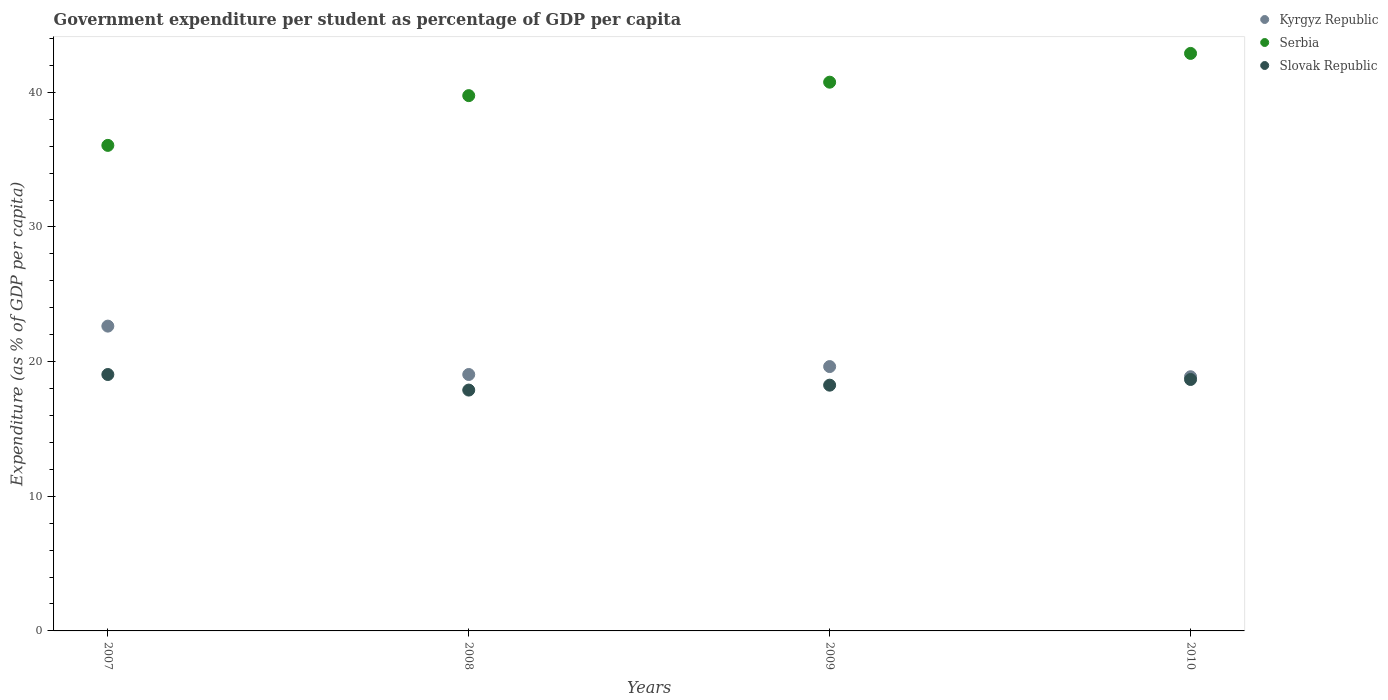How many different coloured dotlines are there?
Your answer should be very brief. 3. What is the percentage of expenditure per student in Kyrgyz Republic in 2007?
Give a very brief answer. 22.64. Across all years, what is the maximum percentage of expenditure per student in Kyrgyz Republic?
Give a very brief answer. 22.64. Across all years, what is the minimum percentage of expenditure per student in Kyrgyz Republic?
Your answer should be very brief. 18.88. In which year was the percentage of expenditure per student in Kyrgyz Republic maximum?
Your answer should be compact. 2007. What is the total percentage of expenditure per student in Serbia in the graph?
Your answer should be compact. 159.45. What is the difference between the percentage of expenditure per student in Serbia in 2007 and that in 2008?
Your response must be concise. -3.69. What is the difference between the percentage of expenditure per student in Kyrgyz Republic in 2009 and the percentage of expenditure per student in Serbia in 2010?
Your response must be concise. -23.26. What is the average percentage of expenditure per student in Kyrgyz Republic per year?
Give a very brief answer. 20.05. In the year 2010, what is the difference between the percentage of expenditure per student in Kyrgyz Republic and percentage of expenditure per student in Slovak Republic?
Ensure brevity in your answer.  0.2. What is the ratio of the percentage of expenditure per student in Slovak Republic in 2008 to that in 2010?
Provide a succinct answer. 0.96. Is the percentage of expenditure per student in Slovak Republic in 2007 less than that in 2010?
Provide a short and direct response. No. Is the difference between the percentage of expenditure per student in Kyrgyz Republic in 2007 and 2008 greater than the difference between the percentage of expenditure per student in Slovak Republic in 2007 and 2008?
Your response must be concise. Yes. What is the difference between the highest and the second highest percentage of expenditure per student in Kyrgyz Republic?
Provide a succinct answer. 3. What is the difference between the highest and the lowest percentage of expenditure per student in Kyrgyz Republic?
Ensure brevity in your answer.  3.76. In how many years, is the percentage of expenditure per student in Slovak Republic greater than the average percentage of expenditure per student in Slovak Republic taken over all years?
Provide a short and direct response. 2. Does the percentage of expenditure per student in Kyrgyz Republic monotonically increase over the years?
Your response must be concise. No. Is the percentage of expenditure per student in Slovak Republic strictly greater than the percentage of expenditure per student in Serbia over the years?
Ensure brevity in your answer.  No. What is the difference between two consecutive major ticks on the Y-axis?
Provide a short and direct response. 10. Are the values on the major ticks of Y-axis written in scientific E-notation?
Provide a short and direct response. No. Does the graph contain grids?
Give a very brief answer. No. Where does the legend appear in the graph?
Your response must be concise. Top right. How many legend labels are there?
Make the answer very short. 3. What is the title of the graph?
Give a very brief answer. Government expenditure per student as percentage of GDP per capita. What is the label or title of the X-axis?
Make the answer very short. Years. What is the label or title of the Y-axis?
Make the answer very short. Expenditure (as % of GDP per capita). What is the Expenditure (as % of GDP per capita) of Kyrgyz Republic in 2007?
Your answer should be compact. 22.64. What is the Expenditure (as % of GDP per capita) in Serbia in 2007?
Your answer should be very brief. 36.06. What is the Expenditure (as % of GDP per capita) in Slovak Republic in 2007?
Your response must be concise. 19.04. What is the Expenditure (as % of GDP per capita) of Kyrgyz Republic in 2008?
Give a very brief answer. 19.04. What is the Expenditure (as % of GDP per capita) of Serbia in 2008?
Make the answer very short. 39.75. What is the Expenditure (as % of GDP per capita) of Slovak Republic in 2008?
Ensure brevity in your answer.  17.89. What is the Expenditure (as % of GDP per capita) of Kyrgyz Republic in 2009?
Keep it short and to the point. 19.63. What is the Expenditure (as % of GDP per capita) of Serbia in 2009?
Provide a short and direct response. 40.75. What is the Expenditure (as % of GDP per capita) of Slovak Republic in 2009?
Offer a very short reply. 18.25. What is the Expenditure (as % of GDP per capita) of Kyrgyz Republic in 2010?
Make the answer very short. 18.88. What is the Expenditure (as % of GDP per capita) of Serbia in 2010?
Offer a terse response. 42.89. What is the Expenditure (as % of GDP per capita) of Slovak Republic in 2010?
Offer a very short reply. 18.67. Across all years, what is the maximum Expenditure (as % of GDP per capita) of Kyrgyz Republic?
Give a very brief answer. 22.64. Across all years, what is the maximum Expenditure (as % of GDP per capita) in Serbia?
Your answer should be very brief. 42.89. Across all years, what is the maximum Expenditure (as % of GDP per capita) in Slovak Republic?
Offer a terse response. 19.04. Across all years, what is the minimum Expenditure (as % of GDP per capita) of Kyrgyz Republic?
Provide a short and direct response. 18.88. Across all years, what is the minimum Expenditure (as % of GDP per capita) of Serbia?
Your response must be concise. 36.06. Across all years, what is the minimum Expenditure (as % of GDP per capita) in Slovak Republic?
Offer a very short reply. 17.89. What is the total Expenditure (as % of GDP per capita) in Kyrgyz Republic in the graph?
Offer a very short reply. 80.19. What is the total Expenditure (as % of GDP per capita) of Serbia in the graph?
Offer a very short reply. 159.45. What is the total Expenditure (as % of GDP per capita) of Slovak Republic in the graph?
Offer a very short reply. 73.85. What is the difference between the Expenditure (as % of GDP per capita) of Kyrgyz Republic in 2007 and that in 2008?
Your response must be concise. 3.59. What is the difference between the Expenditure (as % of GDP per capita) in Serbia in 2007 and that in 2008?
Offer a terse response. -3.69. What is the difference between the Expenditure (as % of GDP per capita) of Slovak Republic in 2007 and that in 2008?
Ensure brevity in your answer.  1.16. What is the difference between the Expenditure (as % of GDP per capita) of Kyrgyz Republic in 2007 and that in 2009?
Give a very brief answer. 3. What is the difference between the Expenditure (as % of GDP per capita) of Serbia in 2007 and that in 2009?
Make the answer very short. -4.69. What is the difference between the Expenditure (as % of GDP per capita) in Slovak Republic in 2007 and that in 2009?
Your answer should be compact. 0.79. What is the difference between the Expenditure (as % of GDP per capita) in Kyrgyz Republic in 2007 and that in 2010?
Your answer should be very brief. 3.76. What is the difference between the Expenditure (as % of GDP per capita) in Serbia in 2007 and that in 2010?
Your response must be concise. -6.83. What is the difference between the Expenditure (as % of GDP per capita) of Slovak Republic in 2007 and that in 2010?
Offer a very short reply. 0.37. What is the difference between the Expenditure (as % of GDP per capita) in Kyrgyz Republic in 2008 and that in 2009?
Provide a succinct answer. -0.59. What is the difference between the Expenditure (as % of GDP per capita) of Serbia in 2008 and that in 2009?
Your answer should be compact. -1. What is the difference between the Expenditure (as % of GDP per capita) in Slovak Republic in 2008 and that in 2009?
Offer a terse response. -0.36. What is the difference between the Expenditure (as % of GDP per capita) in Kyrgyz Republic in 2008 and that in 2010?
Offer a very short reply. 0.17. What is the difference between the Expenditure (as % of GDP per capita) of Serbia in 2008 and that in 2010?
Give a very brief answer. -3.14. What is the difference between the Expenditure (as % of GDP per capita) of Slovak Republic in 2008 and that in 2010?
Provide a succinct answer. -0.79. What is the difference between the Expenditure (as % of GDP per capita) of Kyrgyz Republic in 2009 and that in 2010?
Make the answer very short. 0.75. What is the difference between the Expenditure (as % of GDP per capita) in Serbia in 2009 and that in 2010?
Offer a very short reply. -2.14. What is the difference between the Expenditure (as % of GDP per capita) in Slovak Republic in 2009 and that in 2010?
Provide a short and direct response. -0.42. What is the difference between the Expenditure (as % of GDP per capita) in Kyrgyz Republic in 2007 and the Expenditure (as % of GDP per capita) in Serbia in 2008?
Offer a very short reply. -17.12. What is the difference between the Expenditure (as % of GDP per capita) in Kyrgyz Republic in 2007 and the Expenditure (as % of GDP per capita) in Slovak Republic in 2008?
Keep it short and to the point. 4.75. What is the difference between the Expenditure (as % of GDP per capita) of Serbia in 2007 and the Expenditure (as % of GDP per capita) of Slovak Republic in 2008?
Your answer should be very brief. 18.17. What is the difference between the Expenditure (as % of GDP per capita) of Kyrgyz Republic in 2007 and the Expenditure (as % of GDP per capita) of Serbia in 2009?
Provide a succinct answer. -18.12. What is the difference between the Expenditure (as % of GDP per capita) of Kyrgyz Republic in 2007 and the Expenditure (as % of GDP per capita) of Slovak Republic in 2009?
Provide a short and direct response. 4.38. What is the difference between the Expenditure (as % of GDP per capita) in Serbia in 2007 and the Expenditure (as % of GDP per capita) in Slovak Republic in 2009?
Offer a very short reply. 17.81. What is the difference between the Expenditure (as % of GDP per capita) in Kyrgyz Republic in 2007 and the Expenditure (as % of GDP per capita) in Serbia in 2010?
Make the answer very short. -20.25. What is the difference between the Expenditure (as % of GDP per capita) of Kyrgyz Republic in 2007 and the Expenditure (as % of GDP per capita) of Slovak Republic in 2010?
Give a very brief answer. 3.96. What is the difference between the Expenditure (as % of GDP per capita) in Serbia in 2007 and the Expenditure (as % of GDP per capita) in Slovak Republic in 2010?
Your answer should be compact. 17.38. What is the difference between the Expenditure (as % of GDP per capita) in Kyrgyz Republic in 2008 and the Expenditure (as % of GDP per capita) in Serbia in 2009?
Offer a terse response. -21.71. What is the difference between the Expenditure (as % of GDP per capita) in Kyrgyz Republic in 2008 and the Expenditure (as % of GDP per capita) in Slovak Republic in 2009?
Make the answer very short. 0.79. What is the difference between the Expenditure (as % of GDP per capita) in Serbia in 2008 and the Expenditure (as % of GDP per capita) in Slovak Republic in 2009?
Make the answer very short. 21.5. What is the difference between the Expenditure (as % of GDP per capita) in Kyrgyz Republic in 2008 and the Expenditure (as % of GDP per capita) in Serbia in 2010?
Keep it short and to the point. -23.84. What is the difference between the Expenditure (as % of GDP per capita) in Kyrgyz Republic in 2008 and the Expenditure (as % of GDP per capita) in Slovak Republic in 2010?
Offer a terse response. 0.37. What is the difference between the Expenditure (as % of GDP per capita) in Serbia in 2008 and the Expenditure (as % of GDP per capita) in Slovak Republic in 2010?
Offer a terse response. 21.08. What is the difference between the Expenditure (as % of GDP per capita) in Kyrgyz Republic in 2009 and the Expenditure (as % of GDP per capita) in Serbia in 2010?
Offer a very short reply. -23.26. What is the difference between the Expenditure (as % of GDP per capita) in Kyrgyz Republic in 2009 and the Expenditure (as % of GDP per capita) in Slovak Republic in 2010?
Provide a succinct answer. 0.96. What is the difference between the Expenditure (as % of GDP per capita) in Serbia in 2009 and the Expenditure (as % of GDP per capita) in Slovak Republic in 2010?
Provide a succinct answer. 22.08. What is the average Expenditure (as % of GDP per capita) in Kyrgyz Republic per year?
Offer a very short reply. 20.05. What is the average Expenditure (as % of GDP per capita) in Serbia per year?
Your response must be concise. 39.86. What is the average Expenditure (as % of GDP per capita) in Slovak Republic per year?
Offer a terse response. 18.46. In the year 2007, what is the difference between the Expenditure (as % of GDP per capita) of Kyrgyz Republic and Expenditure (as % of GDP per capita) of Serbia?
Make the answer very short. -13.42. In the year 2007, what is the difference between the Expenditure (as % of GDP per capita) of Kyrgyz Republic and Expenditure (as % of GDP per capita) of Slovak Republic?
Offer a terse response. 3.59. In the year 2007, what is the difference between the Expenditure (as % of GDP per capita) of Serbia and Expenditure (as % of GDP per capita) of Slovak Republic?
Your answer should be very brief. 17.02. In the year 2008, what is the difference between the Expenditure (as % of GDP per capita) in Kyrgyz Republic and Expenditure (as % of GDP per capita) in Serbia?
Offer a very short reply. -20.71. In the year 2008, what is the difference between the Expenditure (as % of GDP per capita) of Kyrgyz Republic and Expenditure (as % of GDP per capita) of Slovak Republic?
Keep it short and to the point. 1.16. In the year 2008, what is the difference between the Expenditure (as % of GDP per capita) in Serbia and Expenditure (as % of GDP per capita) in Slovak Republic?
Ensure brevity in your answer.  21.87. In the year 2009, what is the difference between the Expenditure (as % of GDP per capita) of Kyrgyz Republic and Expenditure (as % of GDP per capita) of Serbia?
Your answer should be compact. -21.12. In the year 2009, what is the difference between the Expenditure (as % of GDP per capita) in Kyrgyz Republic and Expenditure (as % of GDP per capita) in Slovak Republic?
Your answer should be compact. 1.38. In the year 2009, what is the difference between the Expenditure (as % of GDP per capita) in Serbia and Expenditure (as % of GDP per capita) in Slovak Republic?
Your answer should be very brief. 22.5. In the year 2010, what is the difference between the Expenditure (as % of GDP per capita) in Kyrgyz Republic and Expenditure (as % of GDP per capita) in Serbia?
Your answer should be compact. -24.01. In the year 2010, what is the difference between the Expenditure (as % of GDP per capita) of Kyrgyz Republic and Expenditure (as % of GDP per capita) of Slovak Republic?
Provide a succinct answer. 0.2. In the year 2010, what is the difference between the Expenditure (as % of GDP per capita) of Serbia and Expenditure (as % of GDP per capita) of Slovak Republic?
Provide a short and direct response. 24.21. What is the ratio of the Expenditure (as % of GDP per capita) in Kyrgyz Republic in 2007 to that in 2008?
Make the answer very short. 1.19. What is the ratio of the Expenditure (as % of GDP per capita) in Serbia in 2007 to that in 2008?
Offer a very short reply. 0.91. What is the ratio of the Expenditure (as % of GDP per capita) in Slovak Republic in 2007 to that in 2008?
Provide a succinct answer. 1.06. What is the ratio of the Expenditure (as % of GDP per capita) in Kyrgyz Republic in 2007 to that in 2009?
Offer a terse response. 1.15. What is the ratio of the Expenditure (as % of GDP per capita) of Serbia in 2007 to that in 2009?
Your response must be concise. 0.88. What is the ratio of the Expenditure (as % of GDP per capita) of Slovak Republic in 2007 to that in 2009?
Offer a very short reply. 1.04. What is the ratio of the Expenditure (as % of GDP per capita) of Kyrgyz Republic in 2007 to that in 2010?
Keep it short and to the point. 1.2. What is the ratio of the Expenditure (as % of GDP per capita) in Serbia in 2007 to that in 2010?
Offer a very short reply. 0.84. What is the ratio of the Expenditure (as % of GDP per capita) in Slovak Republic in 2007 to that in 2010?
Make the answer very short. 1.02. What is the ratio of the Expenditure (as % of GDP per capita) of Serbia in 2008 to that in 2009?
Your answer should be compact. 0.98. What is the ratio of the Expenditure (as % of GDP per capita) in Slovak Republic in 2008 to that in 2009?
Keep it short and to the point. 0.98. What is the ratio of the Expenditure (as % of GDP per capita) in Kyrgyz Republic in 2008 to that in 2010?
Offer a very short reply. 1.01. What is the ratio of the Expenditure (as % of GDP per capita) of Serbia in 2008 to that in 2010?
Provide a short and direct response. 0.93. What is the ratio of the Expenditure (as % of GDP per capita) in Slovak Republic in 2008 to that in 2010?
Your response must be concise. 0.96. What is the ratio of the Expenditure (as % of GDP per capita) of Kyrgyz Republic in 2009 to that in 2010?
Provide a short and direct response. 1.04. What is the ratio of the Expenditure (as % of GDP per capita) of Serbia in 2009 to that in 2010?
Provide a short and direct response. 0.95. What is the ratio of the Expenditure (as % of GDP per capita) of Slovak Republic in 2009 to that in 2010?
Ensure brevity in your answer.  0.98. What is the difference between the highest and the second highest Expenditure (as % of GDP per capita) in Kyrgyz Republic?
Provide a succinct answer. 3. What is the difference between the highest and the second highest Expenditure (as % of GDP per capita) in Serbia?
Your answer should be compact. 2.14. What is the difference between the highest and the second highest Expenditure (as % of GDP per capita) of Slovak Republic?
Ensure brevity in your answer.  0.37. What is the difference between the highest and the lowest Expenditure (as % of GDP per capita) of Kyrgyz Republic?
Provide a short and direct response. 3.76. What is the difference between the highest and the lowest Expenditure (as % of GDP per capita) of Serbia?
Your answer should be compact. 6.83. What is the difference between the highest and the lowest Expenditure (as % of GDP per capita) of Slovak Republic?
Offer a very short reply. 1.16. 